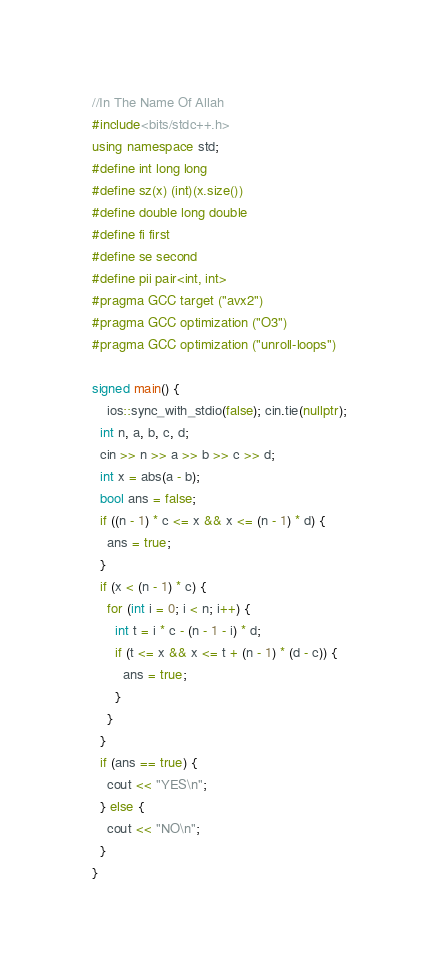Convert code to text. <code><loc_0><loc_0><loc_500><loc_500><_C++_>//In The Name Of Allah
#include<bits/stdc++.h>
using namespace std;
#define int long long
#define sz(x) (int)(x.size())
#define double long double 
#define fi first
#define se second
#define pii pair<int, int>
#pragma GCC target ("avx2")
#pragma GCC optimization ("O3")
#pragma GCC optimization ("unroll-loops")

signed main() {
	ios::sync_with_stdio(false); cin.tie(nullptr);
  int n, a, b, c, d;
  cin >> n >> a >> b >> c >> d;
  int x = abs(a - b);
  bool ans = false;
  if ((n - 1) * c <= x && x <= (n - 1) * d) {
    ans = true;
  }
  if (x < (n - 1) * c) {
    for (int i = 0; i < n; i++) {
      int t = i * c - (n - 1 - i) * d;
      if (t <= x && x <= t + (n - 1) * (d - c)) {
        ans = true;
      }
    }
  }
  if (ans == true) {
    cout << "YES\n";
  } else {
    cout << "NO\n";
  }
}

</code> 